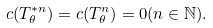Convert formula to latex. <formula><loc_0><loc_0><loc_500><loc_500>c ( T _ { \theta } ^ { * n } ) = c ( T _ { \theta } ^ { n } ) = 0 ( n \in \mathbb { N } ) .</formula> 